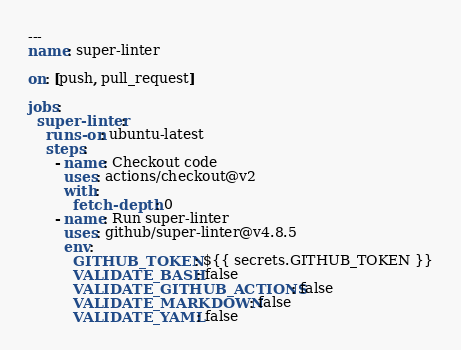<code> <loc_0><loc_0><loc_500><loc_500><_YAML_>---
name: super-linter

on: [push, pull_request]

jobs:
  super-linter:
    runs-on: ubuntu-latest
    steps:
      - name: Checkout code
        uses: actions/checkout@v2
        with:
          fetch-depth: 0
      - name: Run super-linter
        uses: github/super-linter@v4.8.5
        env:
          GITHUB_TOKEN: ${{ secrets.GITHUB_TOKEN }}
          VALIDATE_BASH: false
          VALIDATE_GITHUB_ACTIONS: false
          VALIDATE_MARKDOWN: false
          VALIDATE_YAML: false
</code> 